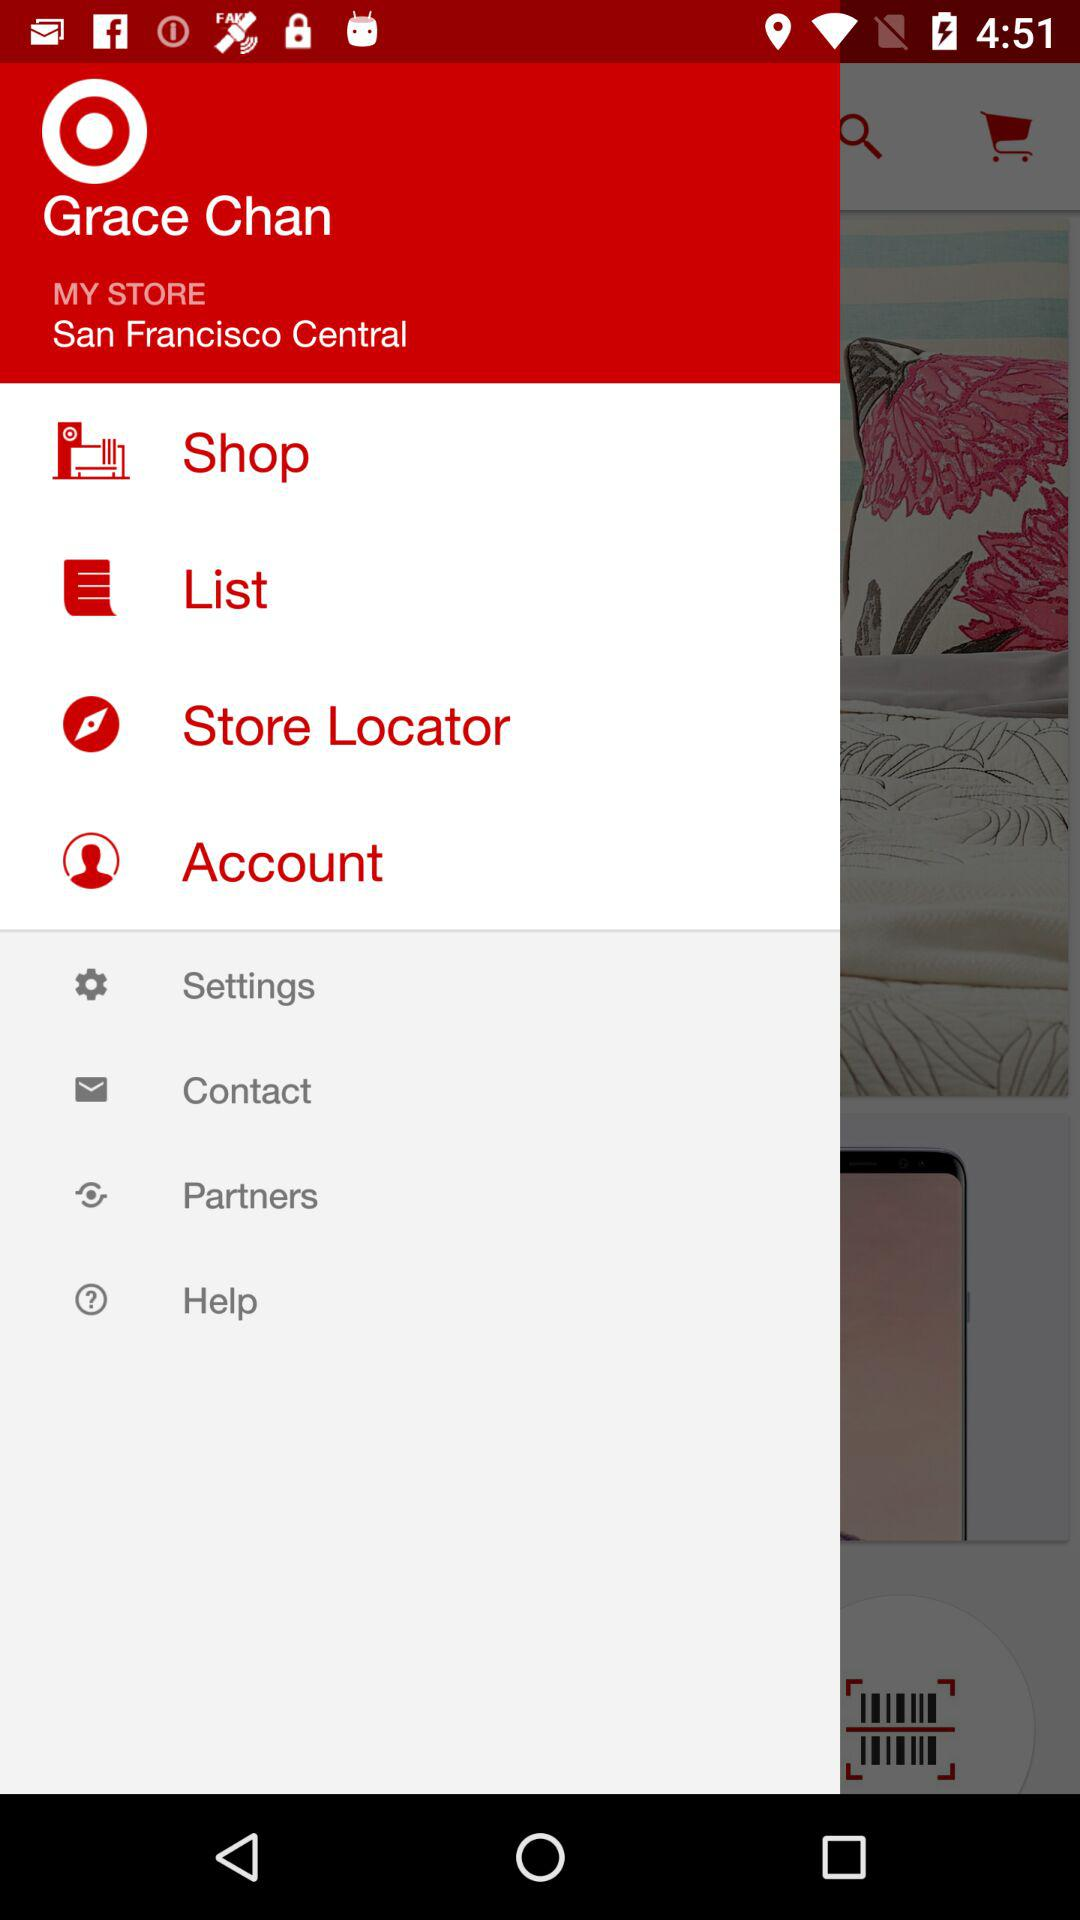At what place is the store located? The store is located at San Francisco Central. 